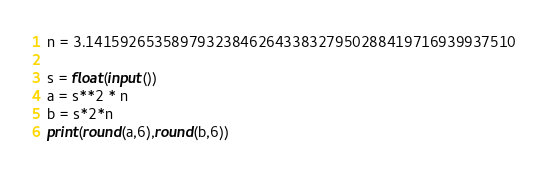Convert code to text. <code><loc_0><loc_0><loc_500><loc_500><_Python_>n = 3.14159265358979323846264338327950288419716939937510

s = float(input())
a = s**2 * n
b = s*2*n
print(round(a,6),round(b,6))
</code> 